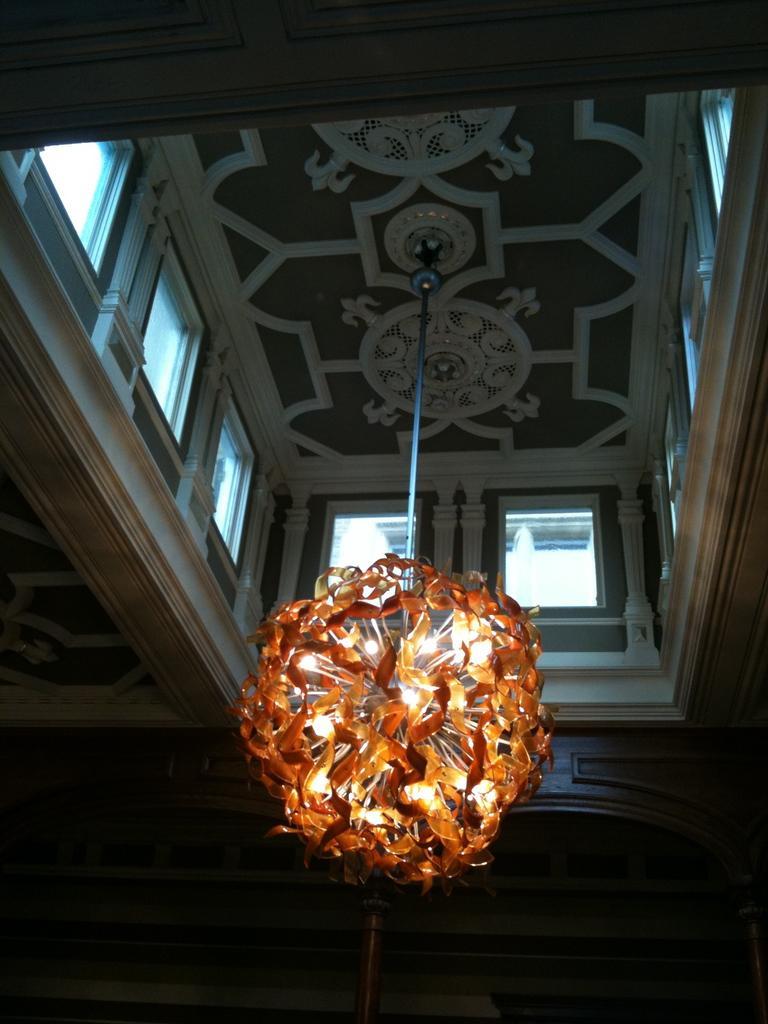Please provide a concise description of this image. An inside picture of a building. Here we can see chandelier and glass windows. 